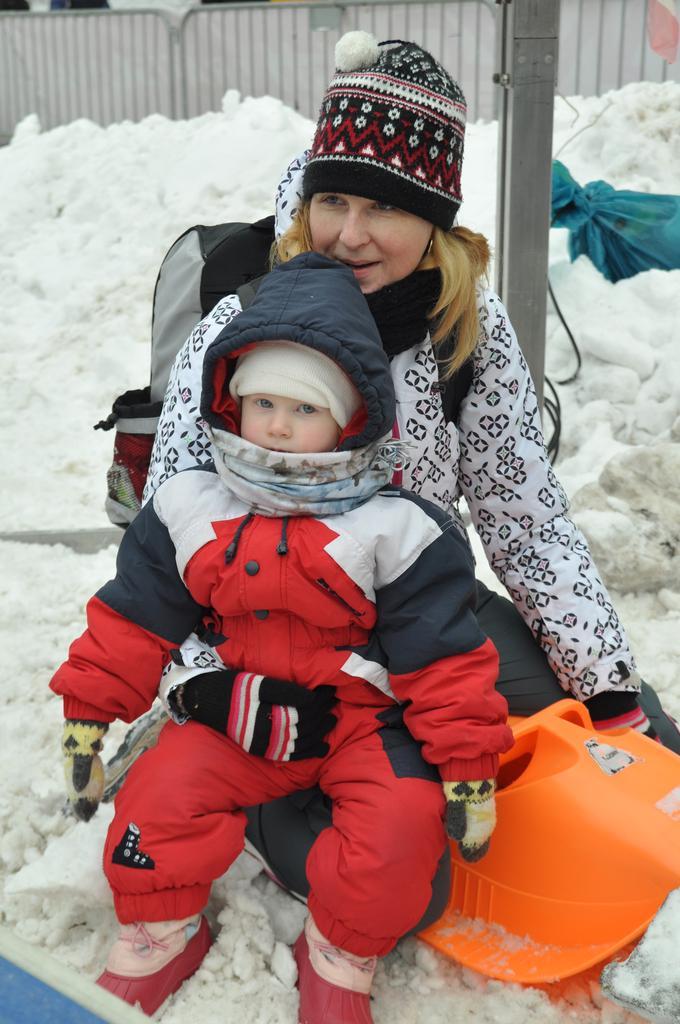Could you give a brief overview of what you see in this image? In the middle of the image a woman is sitting and holding a baby. Behind them there is snow. At the top of the image there is fencing. 